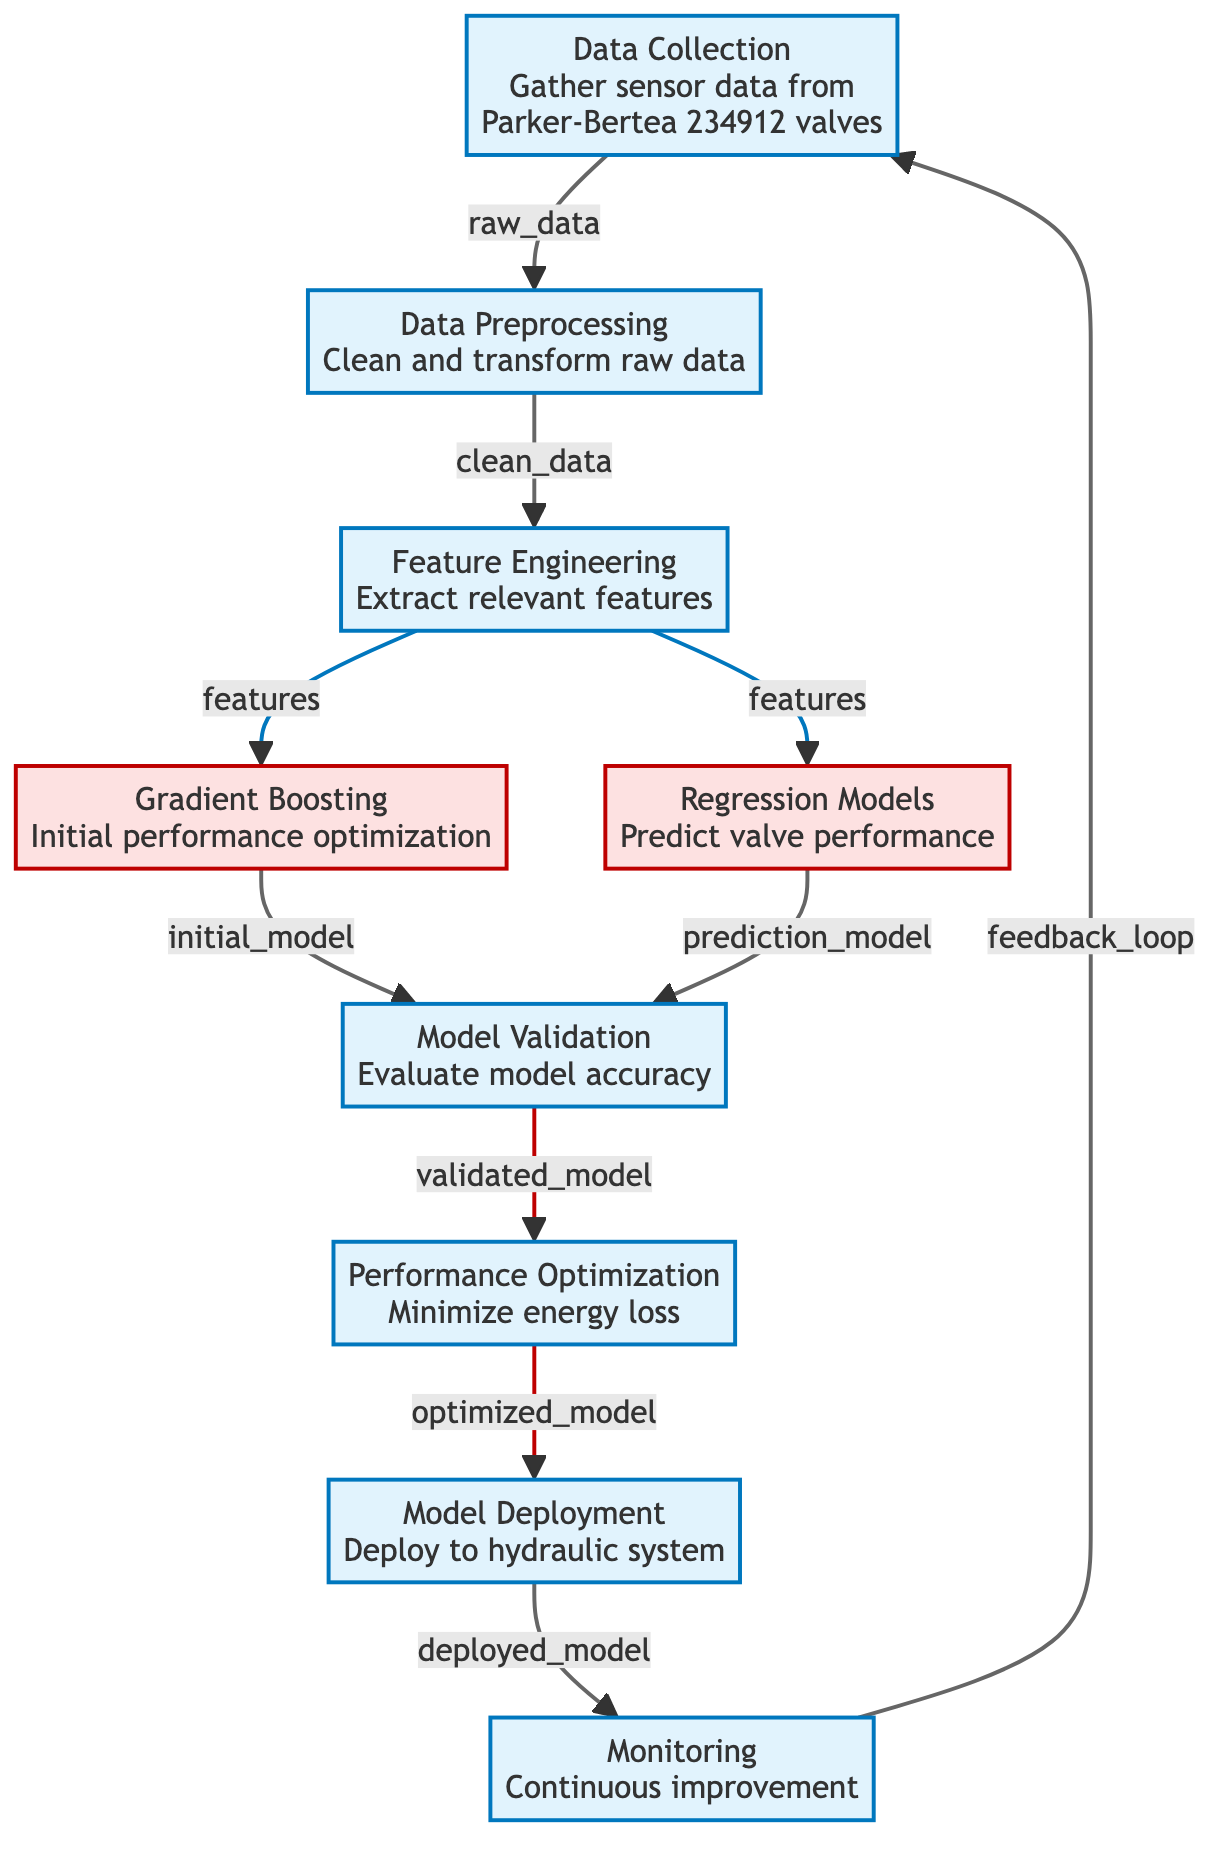What is the first step in the process? The diagram indicates that the first step is "Data Collection", which gathers sensor data from Parker-Bertea 234912 valves.
Answer: Data Collection How many model nodes are present in the diagram? The diagram has two model nodes, which are "Gradient Boosting" and "Regression Models".
Answer: 2 Which node is connected to "Data Preprocessing"? The node "Data Collection" is connected to "Data Preprocessing", indicating the flow of raw data.
Answer: Data Collection What follows "Model Validation"? The next step after "Model Validation" is "Performance Optimization", which focuses on minimizing energy loss.
Answer: Performance Optimization What type of analysis occurs at the "Gradient Boosting" node? The "Gradient Boosting" node represents an initial performance optimization step to enhance the system’s efficiency.
Answer: Initial performance optimization Which nodes are related to "Feature Engineering"? Both "Gradient Boosting" and "Regression Models" are connected to "Feature Engineering", indicating that they utilize the features extracted during this step.
Answer: Gradient Boosting and Regression Models How does the "Monitoring" node contribute to the overall process? The "Monitoring" node feeds back into "Data Collection", creating a feedback loop for continuous improvement in the system.
Answer: Continuous improvement What is the final step in the diagram? The last step indicated in the diagram is "Monitoring", which ensures that the hydraulic system is continuously refined.
Answer: Monitoring Which node represents the deployment of models? "Model Deployment" is the specific node that indicates the deployment of validated models to the hydraulic system.
Answer: Model Deployment 